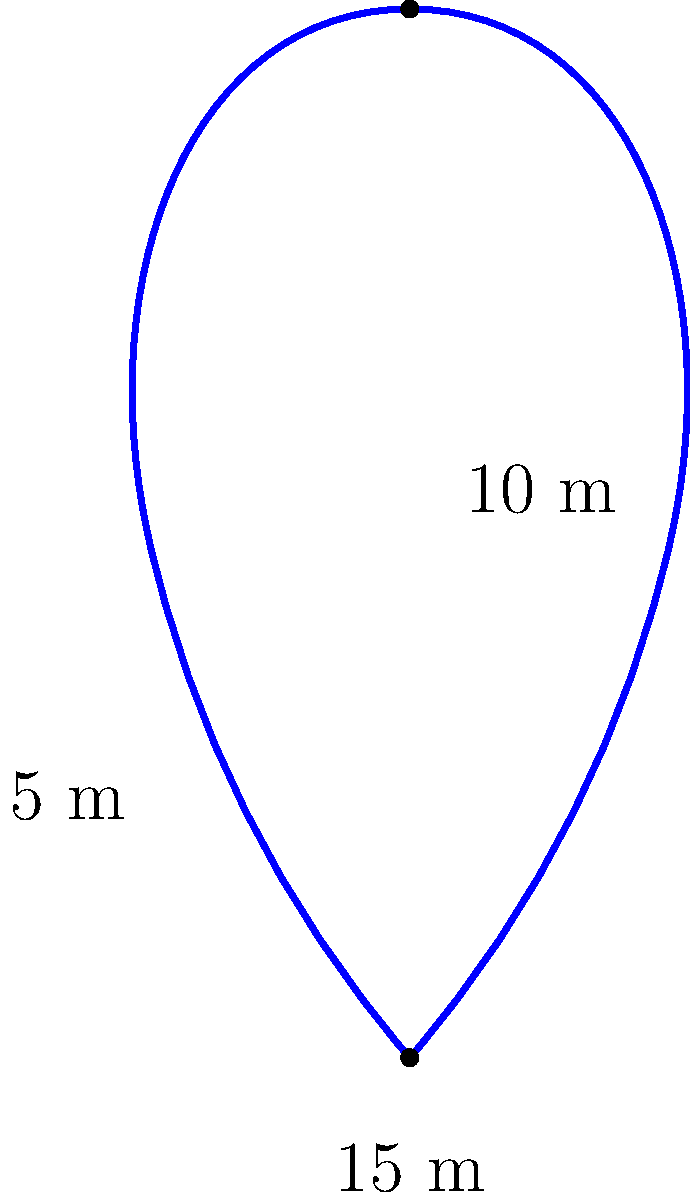A treble clef-shaped garden is being designed for the entrance of Chetham's School of Music. The garden's shape can be approximated by three semicircles: the top loop has a diameter of 10 meters, the middle loop has a diameter of 5 meters, and the bottom loop has a diameter of 15 meters. What is the approximate perimeter of this treble clef-shaped garden? To find the perimeter of the treble clef-shaped garden, we need to calculate the circumference of each semicircle and add them together:

1. Top loop (diameter = 10 m):
   Circumference of semicircle = $\frac{1}{2} \cdot \pi \cdot d = \frac{1}{2} \cdot \pi \cdot 10 = 5\pi$ meters

2. Middle loop (diameter = 5 m):
   Circumference of semicircle = $\frac{1}{2} \cdot \pi \cdot d = \frac{1}{2} \cdot \pi \cdot 5 = 2.5\pi$ meters

3. Bottom loop (diameter = 15 m):
   Circumference of semicircle = $\frac{1}{2} \cdot \pi \cdot d = \frac{1}{2} \cdot \pi \cdot 15 = 7.5\pi$ meters

Total perimeter = Sum of all semicircle circumferences
$$\text{Perimeter} = 5\pi + 2.5\pi + 7.5\pi = 15\pi \text{ meters}$$

Converting to a decimal approximation:
$$15\pi \approx 15 \cdot 3.14159 \approx 47.12 \text{ meters}$$
Answer: Approximately 47.12 meters 